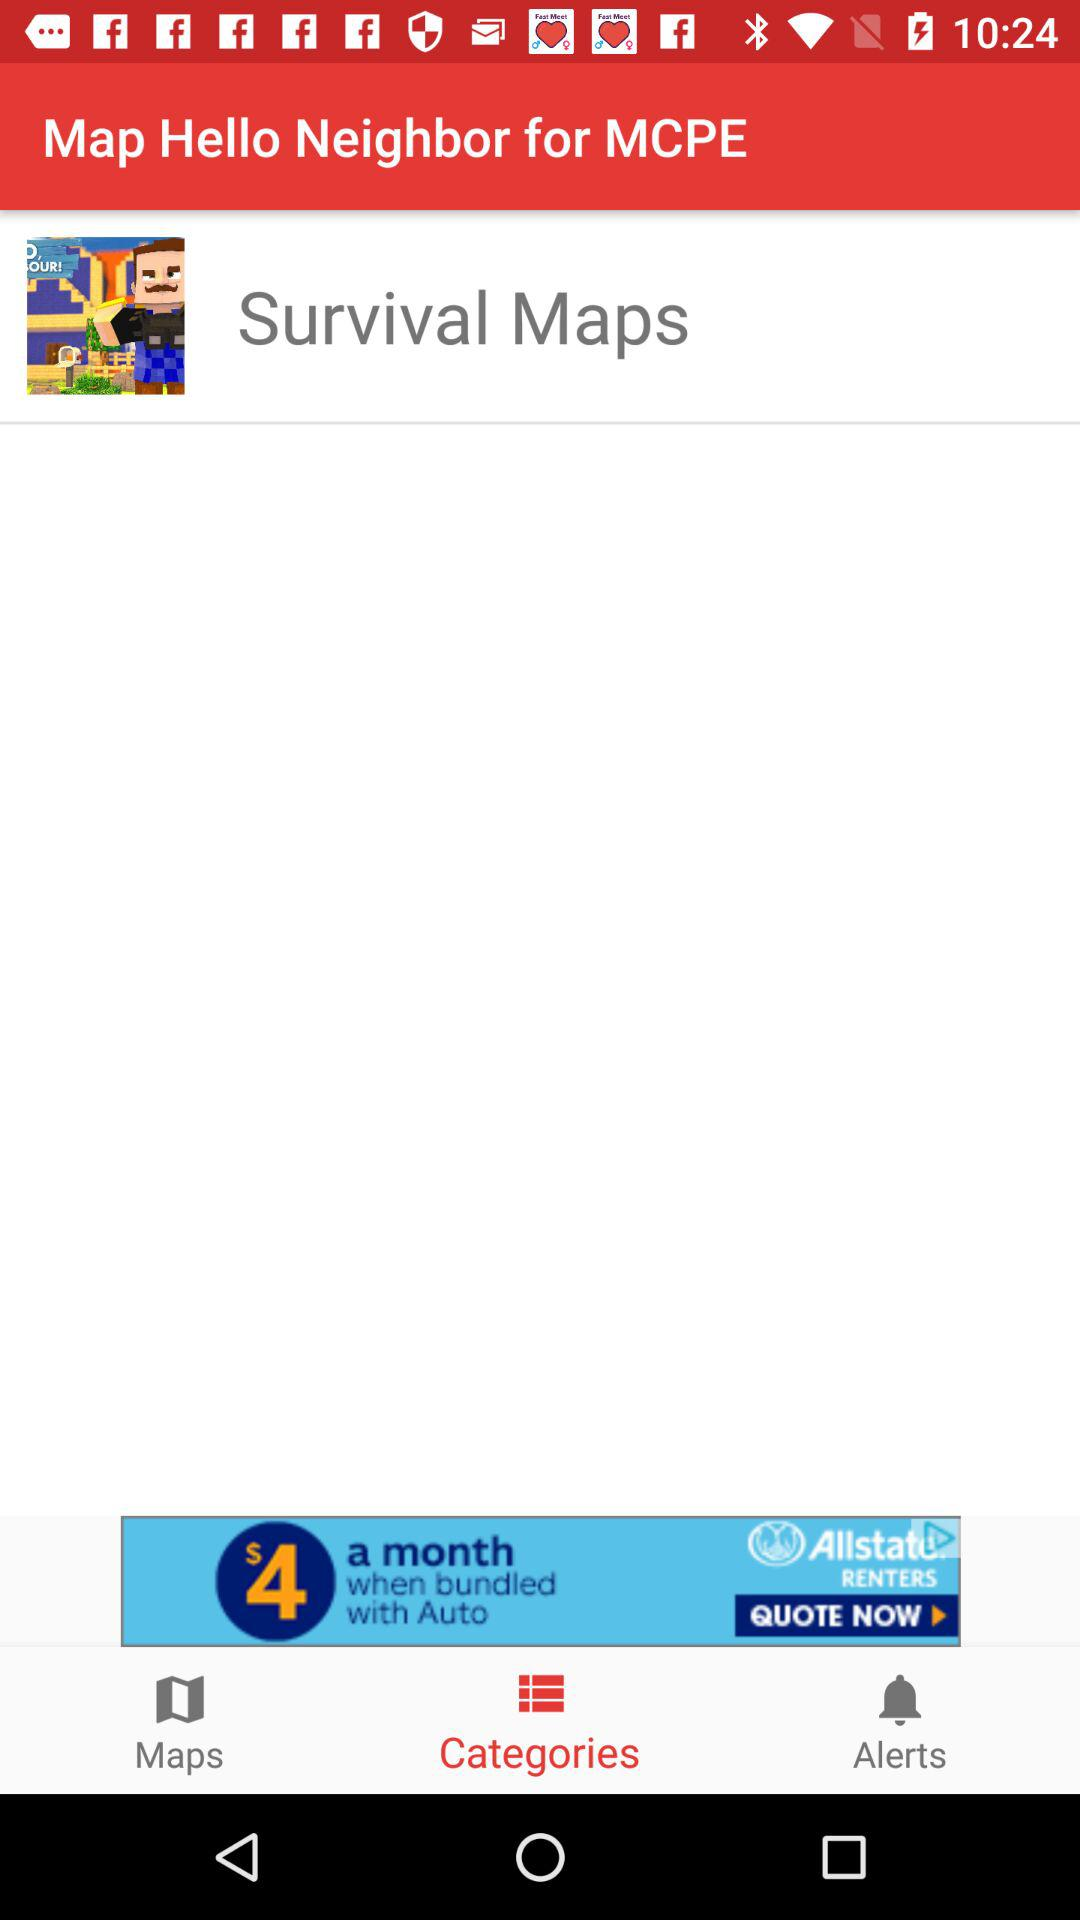Which tab is selected? The selected tab is "Categories". 